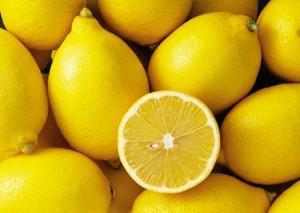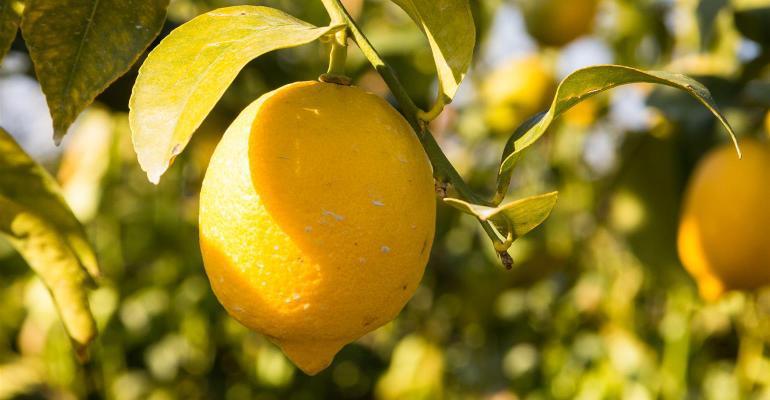The first image is the image on the left, the second image is the image on the right. Given the left and right images, does the statement "In at least one image there is a a cardboard box holding at least 6 rows of wrapped and unwrapped lemon." hold true? Answer yes or no. No. The first image is the image on the left, the second image is the image on the right. Assess this claim about the two images: "There are lemons inside a box.". Correct or not? Answer yes or no. No. 